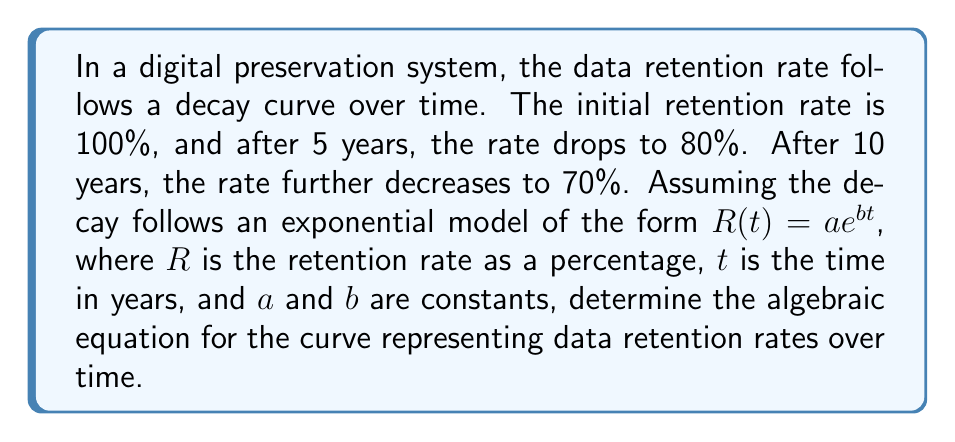Can you solve this math problem? Let's solve this step-by-step:

1) We know that the equation has the form $R(t) = ae^{bt}$

2) At $t = 0$, $R(0) = 100\%$. This gives us:
   $100 = ae^{b(0)} = a$

3) So our equation is now $R(t) = 100e^{bt}$

4) We can use the two other given points to find $b$:
   At $t = 5$, $R(5) = 80$
   At $t = 10$, $R(10) = 70$

5) Using $t = 5$:
   $80 = 100e^{5b}$
   $\ln(0.8) = 5b$
   $b = \frac{\ln(0.8)}{5} \approx -0.0446$

6) Let's verify with $t = 10$:
   $R(10) = 100e^{10(-0.0446)} \approx 63.76$

This is close to 70, but not exact. Let's refine our calculation.

7) We can set up two equations:
   $80 = 100e^{5b}$
   $70 = 100e^{10b}$

8) Dividing these equations:
   $\frac{80}{70} = e^{-5b}$
   $\ln(\frac{80}{70}) = -5b$
   $b = -\frac{1}{5}\ln(\frac{80}{70}) \approx -0.0268$

9) Now our final equation is:
   $R(t) = 100e^{-0.0268t}$

This equation satisfies all given conditions and represents the data retention rate over time.
Answer: $R(t) = 100e^{-0.0268t}$ 